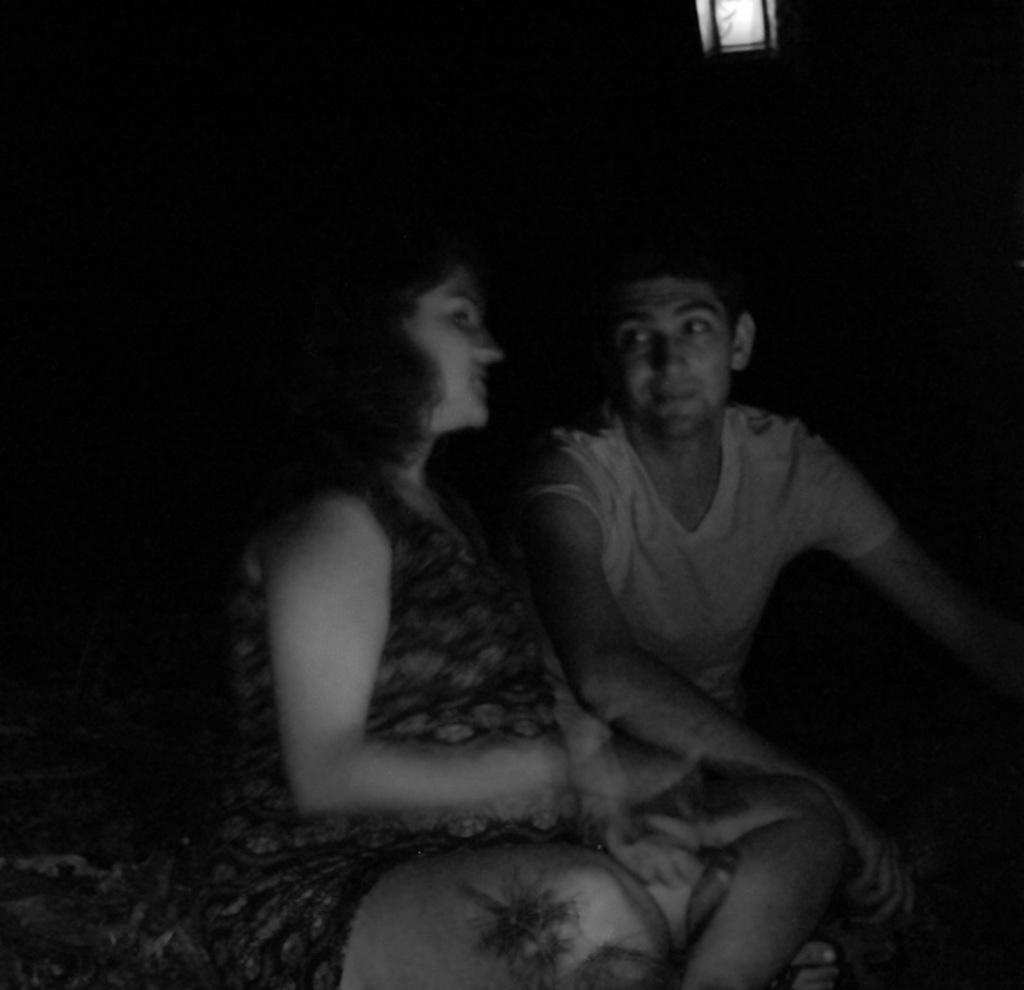What type of picture is in the image? There is a black and white picture in the image. Who or what is depicted in the picture? The picture contains a woman and a man. What are the woman and man doing in the picture? The woman and man are sitting. What is the color of the background in the image? The background of the image is dark. Can you see any pigs in the image? No, there are no pigs present in the image. What type of frog is sitting next to the woman in the image? There is no frog depicted in the image; it features a woman and a man sitting. 